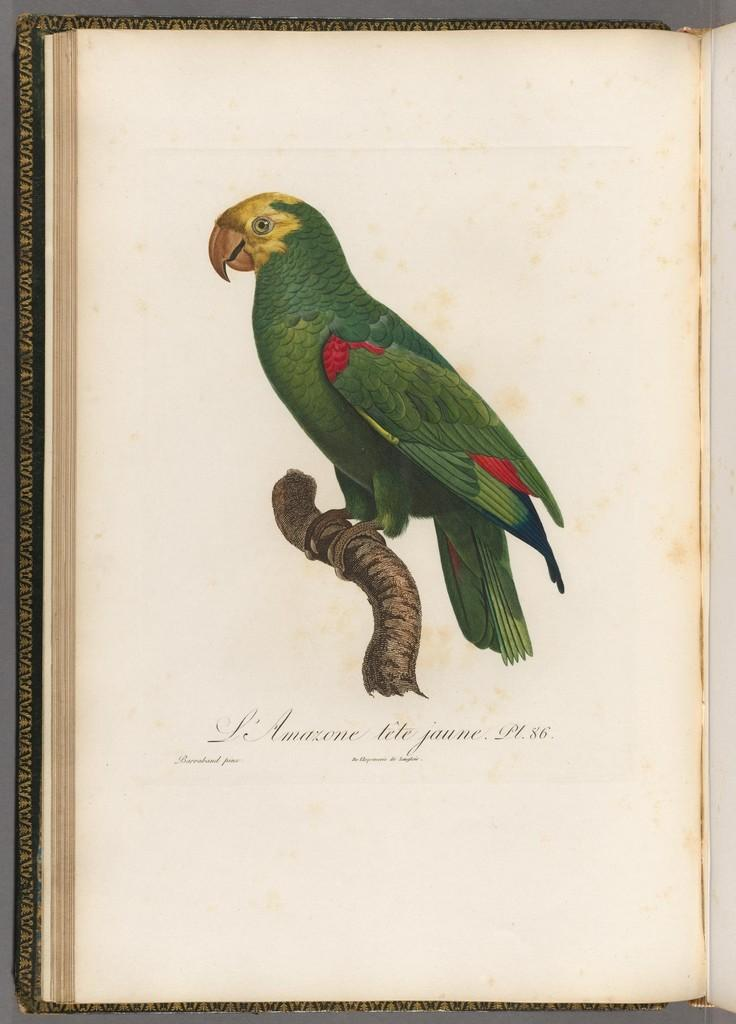What is the main subject of the image? The main subject of the image is a parrot portrait. What type of lunch is the governor eating in the image? There is no governor or lunch present in the image; it features a parrot portrait. What color is the berry that the parrot is holding in the image? There is no berry or parrot holding anything in the image; it is a portrait of a parrot. 